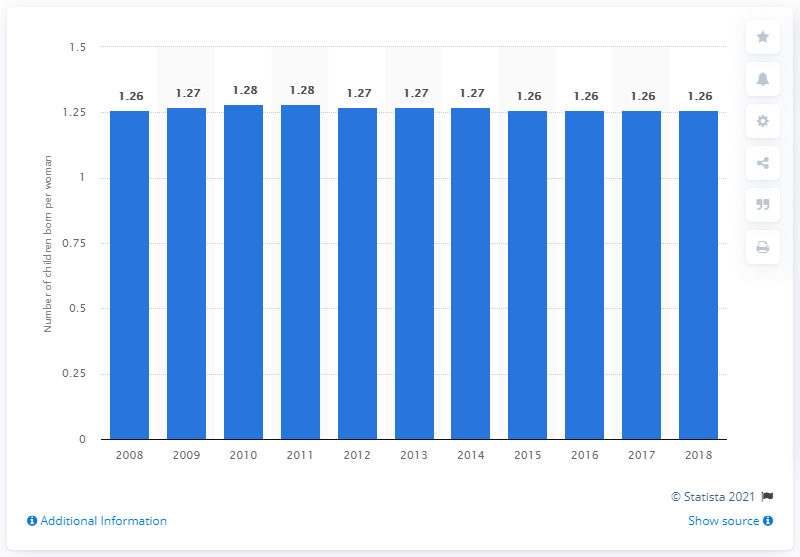Highlight a few significant elements in this photo. According to data from 2018, the fertility rate in Moldova was 1.26. 